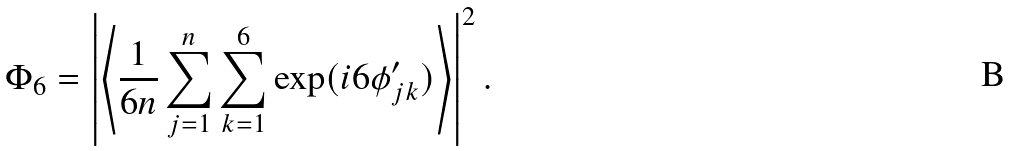Convert formula to latex. <formula><loc_0><loc_0><loc_500><loc_500>\Phi _ { 6 } = \left | \left \langle \frac { 1 } { 6 n } \sum _ { j = 1 } ^ { n } \sum _ { k = 1 } ^ { 6 } \exp ( i 6 \phi ^ { \prime } _ { j k } ) \right \rangle \right | ^ { 2 } .</formula> 